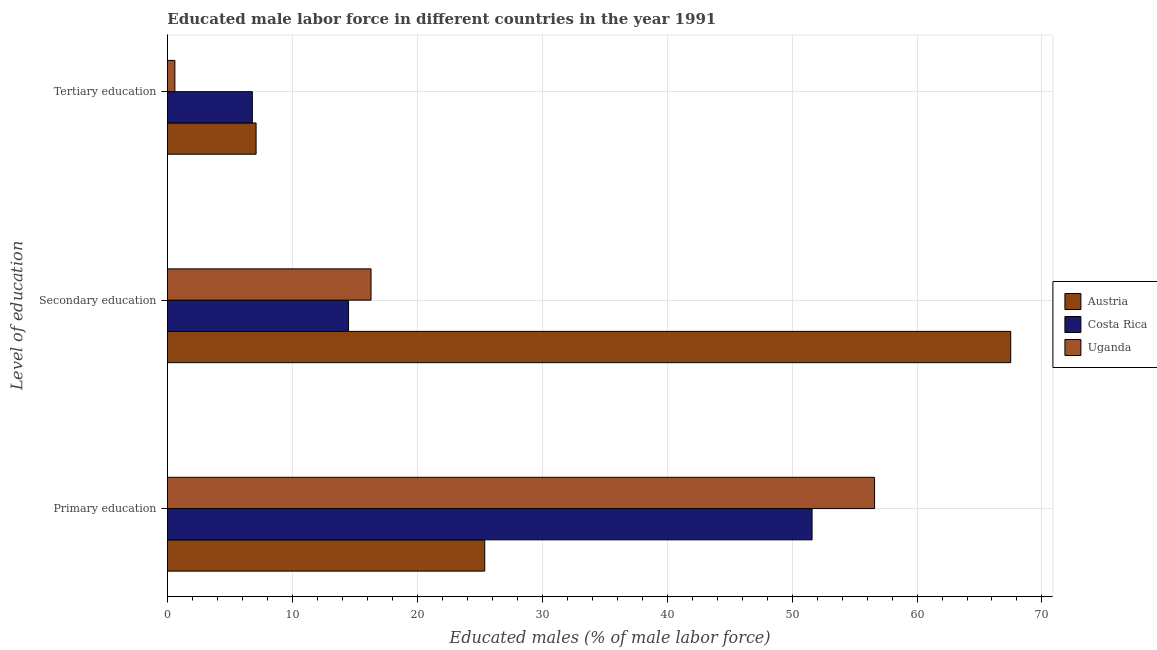How many groups of bars are there?
Provide a short and direct response. 3. Are the number of bars on each tick of the Y-axis equal?
Keep it short and to the point. Yes. How many bars are there on the 3rd tick from the top?
Your answer should be very brief. 3. How many bars are there on the 3rd tick from the bottom?
Provide a succinct answer. 3. What is the label of the 2nd group of bars from the top?
Your response must be concise. Secondary education. What is the percentage of male labor force who received secondary education in Uganda?
Your answer should be very brief. 16.3. Across all countries, what is the maximum percentage of male labor force who received secondary education?
Offer a very short reply. 67.5. Across all countries, what is the minimum percentage of male labor force who received tertiary education?
Offer a terse response. 0.6. What is the total percentage of male labor force who received tertiary education in the graph?
Your answer should be very brief. 14.5. What is the difference between the percentage of male labor force who received primary education in Austria and that in Uganda?
Provide a short and direct response. -31.2. What is the difference between the percentage of male labor force who received tertiary education in Costa Rica and the percentage of male labor force who received secondary education in Uganda?
Your answer should be compact. -9.5. What is the average percentage of male labor force who received primary education per country?
Your response must be concise. 44.53. What is the difference between the percentage of male labor force who received tertiary education and percentage of male labor force who received primary education in Uganda?
Your answer should be very brief. -56. In how many countries, is the percentage of male labor force who received primary education greater than 2 %?
Your answer should be very brief. 3. What is the ratio of the percentage of male labor force who received tertiary education in Austria to that in Costa Rica?
Ensure brevity in your answer.  1.04. What is the difference between the highest and the second highest percentage of male labor force who received tertiary education?
Give a very brief answer. 0.3. In how many countries, is the percentage of male labor force who received tertiary education greater than the average percentage of male labor force who received tertiary education taken over all countries?
Offer a very short reply. 2. Is the sum of the percentage of male labor force who received primary education in Austria and Uganda greater than the maximum percentage of male labor force who received tertiary education across all countries?
Make the answer very short. Yes. What does the 1st bar from the top in Primary education represents?
Your answer should be very brief. Uganda. How many countries are there in the graph?
Provide a succinct answer. 3. What is the difference between two consecutive major ticks on the X-axis?
Your response must be concise. 10. Does the graph contain any zero values?
Your answer should be compact. No. Where does the legend appear in the graph?
Offer a very short reply. Center right. What is the title of the graph?
Give a very brief answer. Educated male labor force in different countries in the year 1991. What is the label or title of the X-axis?
Your answer should be very brief. Educated males (% of male labor force). What is the label or title of the Y-axis?
Make the answer very short. Level of education. What is the Educated males (% of male labor force) in Austria in Primary education?
Your answer should be compact. 25.4. What is the Educated males (% of male labor force) in Costa Rica in Primary education?
Your response must be concise. 51.6. What is the Educated males (% of male labor force) in Uganda in Primary education?
Provide a succinct answer. 56.6. What is the Educated males (% of male labor force) in Austria in Secondary education?
Provide a succinct answer. 67.5. What is the Educated males (% of male labor force) of Costa Rica in Secondary education?
Ensure brevity in your answer.  14.5. What is the Educated males (% of male labor force) in Uganda in Secondary education?
Provide a succinct answer. 16.3. What is the Educated males (% of male labor force) in Austria in Tertiary education?
Give a very brief answer. 7.1. What is the Educated males (% of male labor force) in Costa Rica in Tertiary education?
Give a very brief answer. 6.8. What is the Educated males (% of male labor force) of Uganda in Tertiary education?
Your answer should be very brief. 0.6. Across all Level of education, what is the maximum Educated males (% of male labor force) of Austria?
Give a very brief answer. 67.5. Across all Level of education, what is the maximum Educated males (% of male labor force) in Costa Rica?
Your answer should be very brief. 51.6. Across all Level of education, what is the maximum Educated males (% of male labor force) in Uganda?
Give a very brief answer. 56.6. Across all Level of education, what is the minimum Educated males (% of male labor force) in Austria?
Give a very brief answer. 7.1. Across all Level of education, what is the minimum Educated males (% of male labor force) of Costa Rica?
Offer a very short reply. 6.8. Across all Level of education, what is the minimum Educated males (% of male labor force) of Uganda?
Your response must be concise. 0.6. What is the total Educated males (% of male labor force) of Austria in the graph?
Ensure brevity in your answer.  100. What is the total Educated males (% of male labor force) of Costa Rica in the graph?
Keep it short and to the point. 72.9. What is the total Educated males (% of male labor force) of Uganda in the graph?
Ensure brevity in your answer.  73.5. What is the difference between the Educated males (% of male labor force) in Austria in Primary education and that in Secondary education?
Provide a succinct answer. -42.1. What is the difference between the Educated males (% of male labor force) of Costa Rica in Primary education and that in Secondary education?
Provide a short and direct response. 37.1. What is the difference between the Educated males (% of male labor force) in Uganda in Primary education and that in Secondary education?
Your response must be concise. 40.3. What is the difference between the Educated males (% of male labor force) in Costa Rica in Primary education and that in Tertiary education?
Offer a terse response. 44.8. What is the difference between the Educated males (% of male labor force) of Uganda in Primary education and that in Tertiary education?
Give a very brief answer. 56. What is the difference between the Educated males (% of male labor force) in Austria in Secondary education and that in Tertiary education?
Keep it short and to the point. 60.4. What is the difference between the Educated males (% of male labor force) of Costa Rica in Secondary education and that in Tertiary education?
Your response must be concise. 7.7. What is the difference between the Educated males (% of male labor force) in Austria in Primary education and the Educated males (% of male labor force) in Costa Rica in Secondary education?
Offer a terse response. 10.9. What is the difference between the Educated males (% of male labor force) of Austria in Primary education and the Educated males (% of male labor force) of Uganda in Secondary education?
Provide a short and direct response. 9.1. What is the difference between the Educated males (% of male labor force) in Costa Rica in Primary education and the Educated males (% of male labor force) in Uganda in Secondary education?
Make the answer very short. 35.3. What is the difference between the Educated males (% of male labor force) of Austria in Primary education and the Educated males (% of male labor force) of Uganda in Tertiary education?
Ensure brevity in your answer.  24.8. What is the difference between the Educated males (% of male labor force) in Austria in Secondary education and the Educated males (% of male labor force) in Costa Rica in Tertiary education?
Your response must be concise. 60.7. What is the difference between the Educated males (% of male labor force) of Austria in Secondary education and the Educated males (% of male labor force) of Uganda in Tertiary education?
Your response must be concise. 66.9. What is the average Educated males (% of male labor force) in Austria per Level of education?
Offer a very short reply. 33.33. What is the average Educated males (% of male labor force) of Costa Rica per Level of education?
Offer a terse response. 24.3. What is the difference between the Educated males (% of male labor force) of Austria and Educated males (% of male labor force) of Costa Rica in Primary education?
Offer a terse response. -26.2. What is the difference between the Educated males (% of male labor force) of Austria and Educated males (% of male labor force) of Uganda in Primary education?
Offer a terse response. -31.2. What is the difference between the Educated males (% of male labor force) of Austria and Educated males (% of male labor force) of Costa Rica in Secondary education?
Provide a short and direct response. 53. What is the difference between the Educated males (% of male labor force) of Austria and Educated males (% of male labor force) of Uganda in Secondary education?
Your answer should be very brief. 51.2. What is the difference between the Educated males (% of male labor force) in Costa Rica and Educated males (% of male labor force) in Uganda in Secondary education?
Your response must be concise. -1.8. What is the ratio of the Educated males (% of male labor force) of Austria in Primary education to that in Secondary education?
Provide a short and direct response. 0.38. What is the ratio of the Educated males (% of male labor force) in Costa Rica in Primary education to that in Secondary education?
Make the answer very short. 3.56. What is the ratio of the Educated males (% of male labor force) of Uganda in Primary education to that in Secondary education?
Provide a succinct answer. 3.47. What is the ratio of the Educated males (% of male labor force) in Austria in Primary education to that in Tertiary education?
Ensure brevity in your answer.  3.58. What is the ratio of the Educated males (% of male labor force) of Costa Rica in Primary education to that in Tertiary education?
Ensure brevity in your answer.  7.59. What is the ratio of the Educated males (% of male labor force) of Uganda in Primary education to that in Tertiary education?
Offer a very short reply. 94.33. What is the ratio of the Educated males (% of male labor force) of Austria in Secondary education to that in Tertiary education?
Give a very brief answer. 9.51. What is the ratio of the Educated males (% of male labor force) of Costa Rica in Secondary education to that in Tertiary education?
Your response must be concise. 2.13. What is the ratio of the Educated males (% of male labor force) in Uganda in Secondary education to that in Tertiary education?
Your answer should be compact. 27.17. What is the difference between the highest and the second highest Educated males (% of male labor force) of Austria?
Provide a succinct answer. 42.1. What is the difference between the highest and the second highest Educated males (% of male labor force) of Costa Rica?
Your answer should be compact. 37.1. What is the difference between the highest and the second highest Educated males (% of male labor force) in Uganda?
Offer a very short reply. 40.3. What is the difference between the highest and the lowest Educated males (% of male labor force) of Austria?
Provide a short and direct response. 60.4. What is the difference between the highest and the lowest Educated males (% of male labor force) of Costa Rica?
Give a very brief answer. 44.8. 